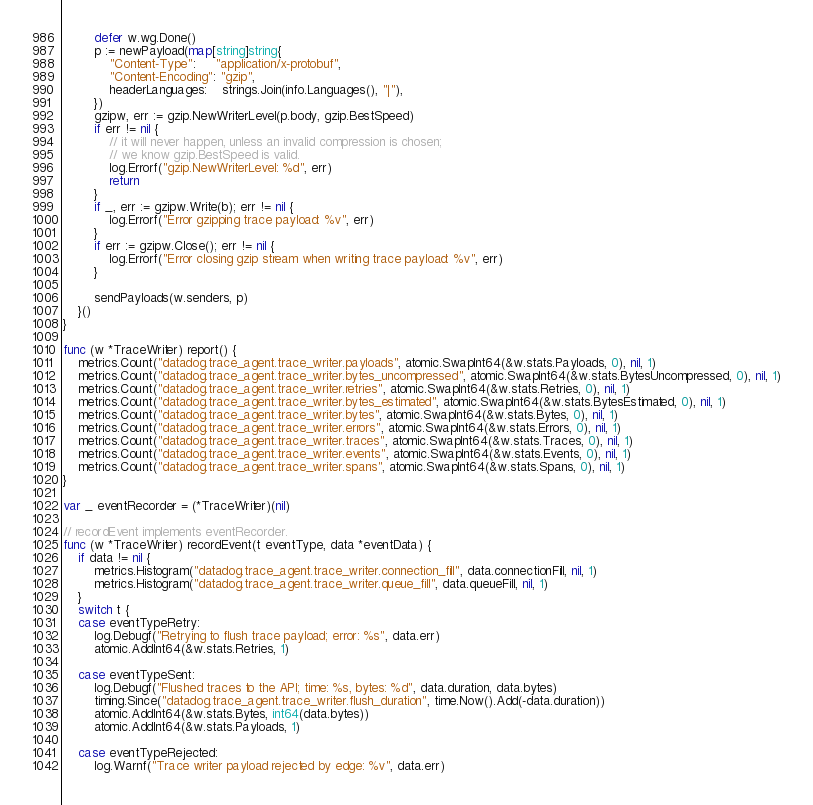Convert code to text. <code><loc_0><loc_0><loc_500><loc_500><_Go_>		defer w.wg.Done()
		p := newPayload(map[string]string{
			"Content-Type":     "application/x-protobuf",
			"Content-Encoding": "gzip",
			headerLanguages:    strings.Join(info.Languages(), "|"),
		})
		gzipw, err := gzip.NewWriterLevel(p.body, gzip.BestSpeed)
		if err != nil {
			// it will never happen, unless an invalid compression is chosen;
			// we know gzip.BestSpeed is valid.
			log.Errorf("gzip.NewWriterLevel: %d", err)
			return
		}
		if _, err := gzipw.Write(b); err != nil {
			log.Errorf("Error gzipping trace payload: %v", err)
		}
		if err := gzipw.Close(); err != nil {
			log.Errorf("Error closing gzip stream when writing trace payload: %v", err)
		}

		sendPayloads(w.senders, p)
	}()
}

func (w *TraceWriter) report() {
	metrics.Count("datadog.trace_agent.trace_writer.payloads", atomic.SwapInt64(&w.stats.Payloads, 0), nil, 1)
	metrics.Count("datadog.trace_agent.trace_writer.bytes_uncompressed", atomic.SwapInt64(&w.stats.BytesUncompressed, 0), nil, 1)
	metrics.Count("datadog.trace_agent.trace_writer.retries", atomic.SwapInt64(&w.stats.Retries, 0), nil, 1)
	metrics.Count("datadog.trace_agent.trace_writer.bytes_estimated", atomic.SwapInt64(&w.stats.BytesEstimated, 0), nil, 1)
	metrics.Count("datadog.trace_agent.trace_writer.bytes", atomic.SwapInt64(&w.stats.Bytes, 0), nil, 1)
	metrics.Count("datadog.trace_agent.trace_writer.errors", atomic.SwapInt64(&w.stats.Errors, 0), nil, 1)
	metrics.Count("datadog.trace_agent.trace_writer.traces", atomic.SwapInt64(&w.stats.Traces, 0), nil, 1)
	metrics.Count("datadog.trace_agent.trace_writer.events", atomic.SwapInt64(&w.stats.Events, 0), nil, 1)
	metrics.Count("datadog.trace_agent.trace_writer.spans", atomic.SwapInt64(&w.stats.Spans, 0), nil, 1)
}

var _ eventRecorder = (*TraceWriter)(nil)

// recordEvent implements eventRecorder.
func (w *TraceWriter) recordEvent(t eventType, data *eventData) {
	if data != nil {
		metrics.Histogram("datadog.trace_agent.trace_writer.connection_fill", data.connectionFill, nil, 1)
		metrics.Histogram("datadog.trace_agent.trace_writer.queue_fill", data.queueFill, nil, 1)
	}
	switch t {
	case eventTypeRetry:
		log.Debugf("Retrying to flush trace payload; error: %s", data.err)
		atomic.AddInt64(&w.stats.Retries, 1)

	case eventTypeSent:
		log.Debugf("Flushed traces to the API; time: %s, bytes: %d", data.duration, data.bytes)
		timing.Since("datadog.trace_agent.trace_writer.flush_duration", time.Now().Add(-data.duration))
		atomic.AddInt64(&w.stats.Bytes, int64(data.bytes))
		atomic.AddInt64(&w.stats.Payloads, 1)

	case eventTypeRejected:
		log.Warnf("Trace writer payload rejected by edge: %v", data.err)</code> 